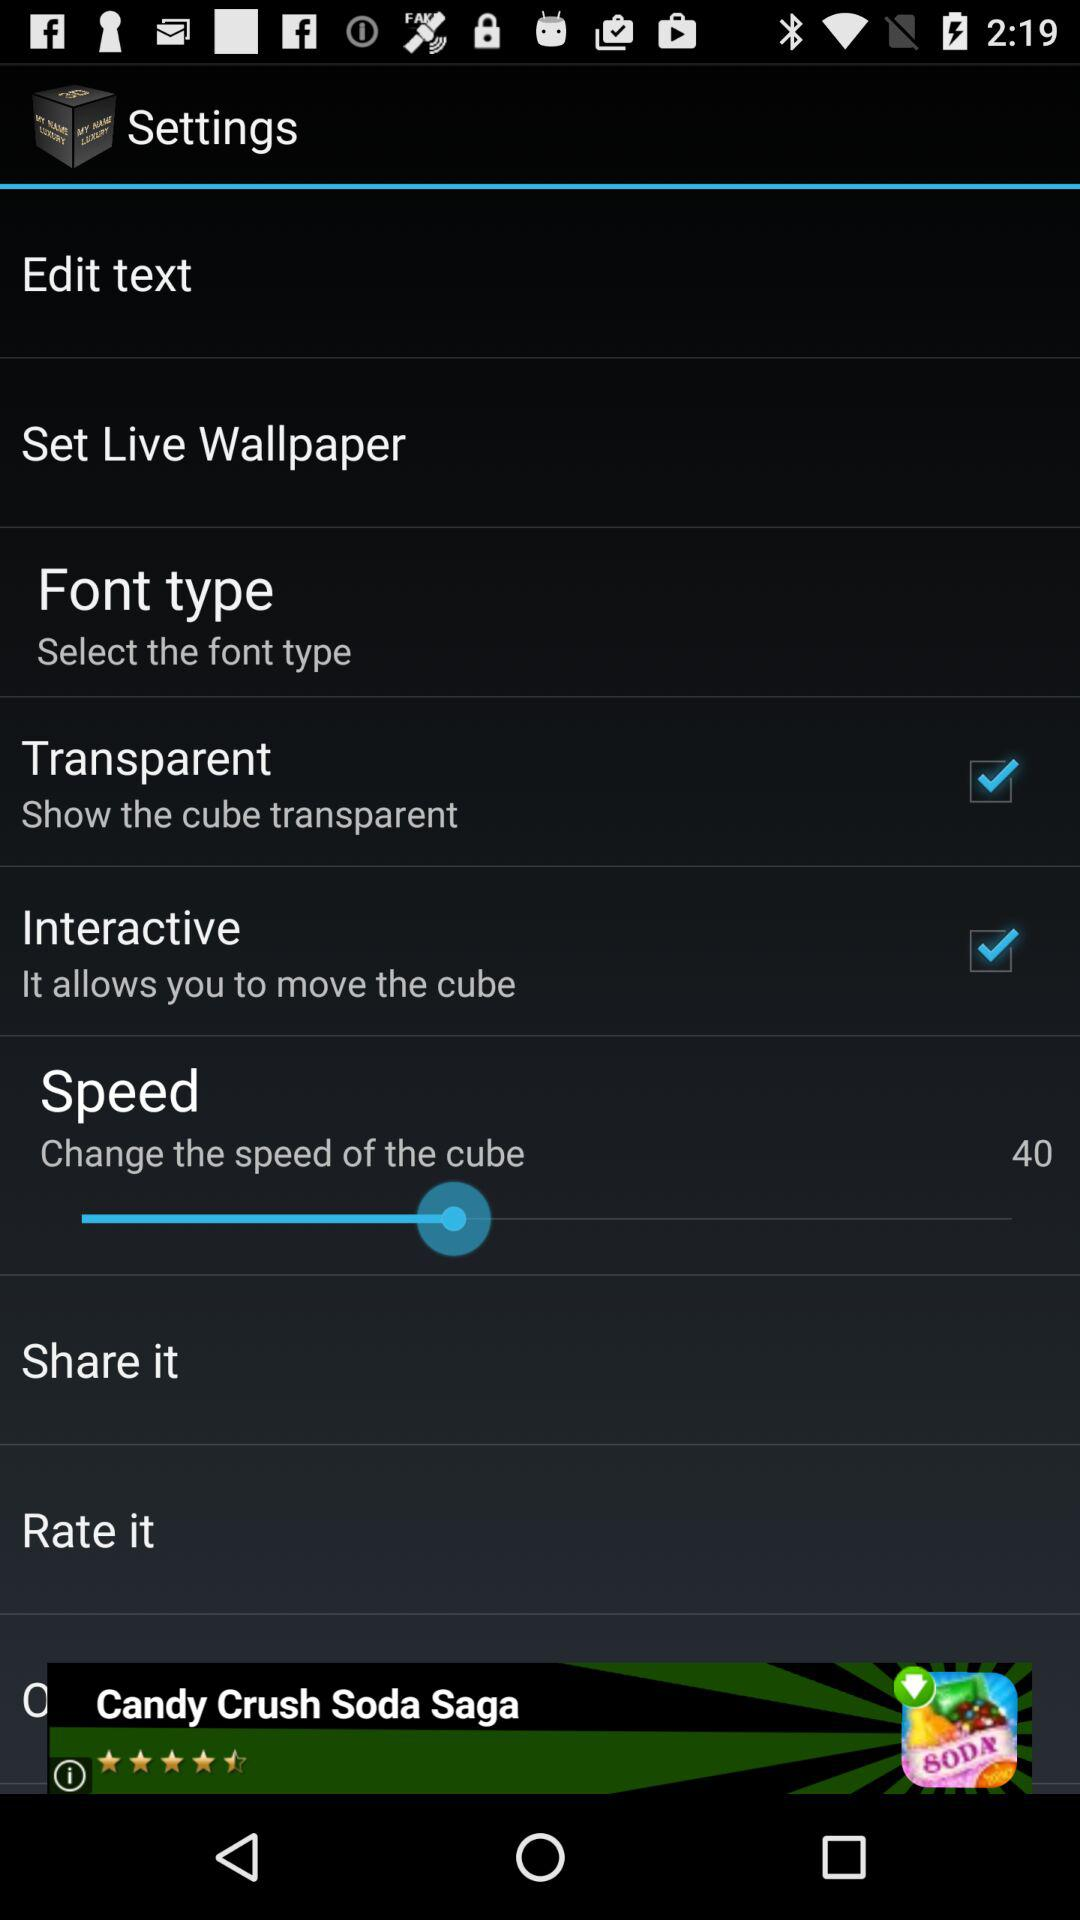Which option was selected? The selected options were "Transparent" and "Interactive". 